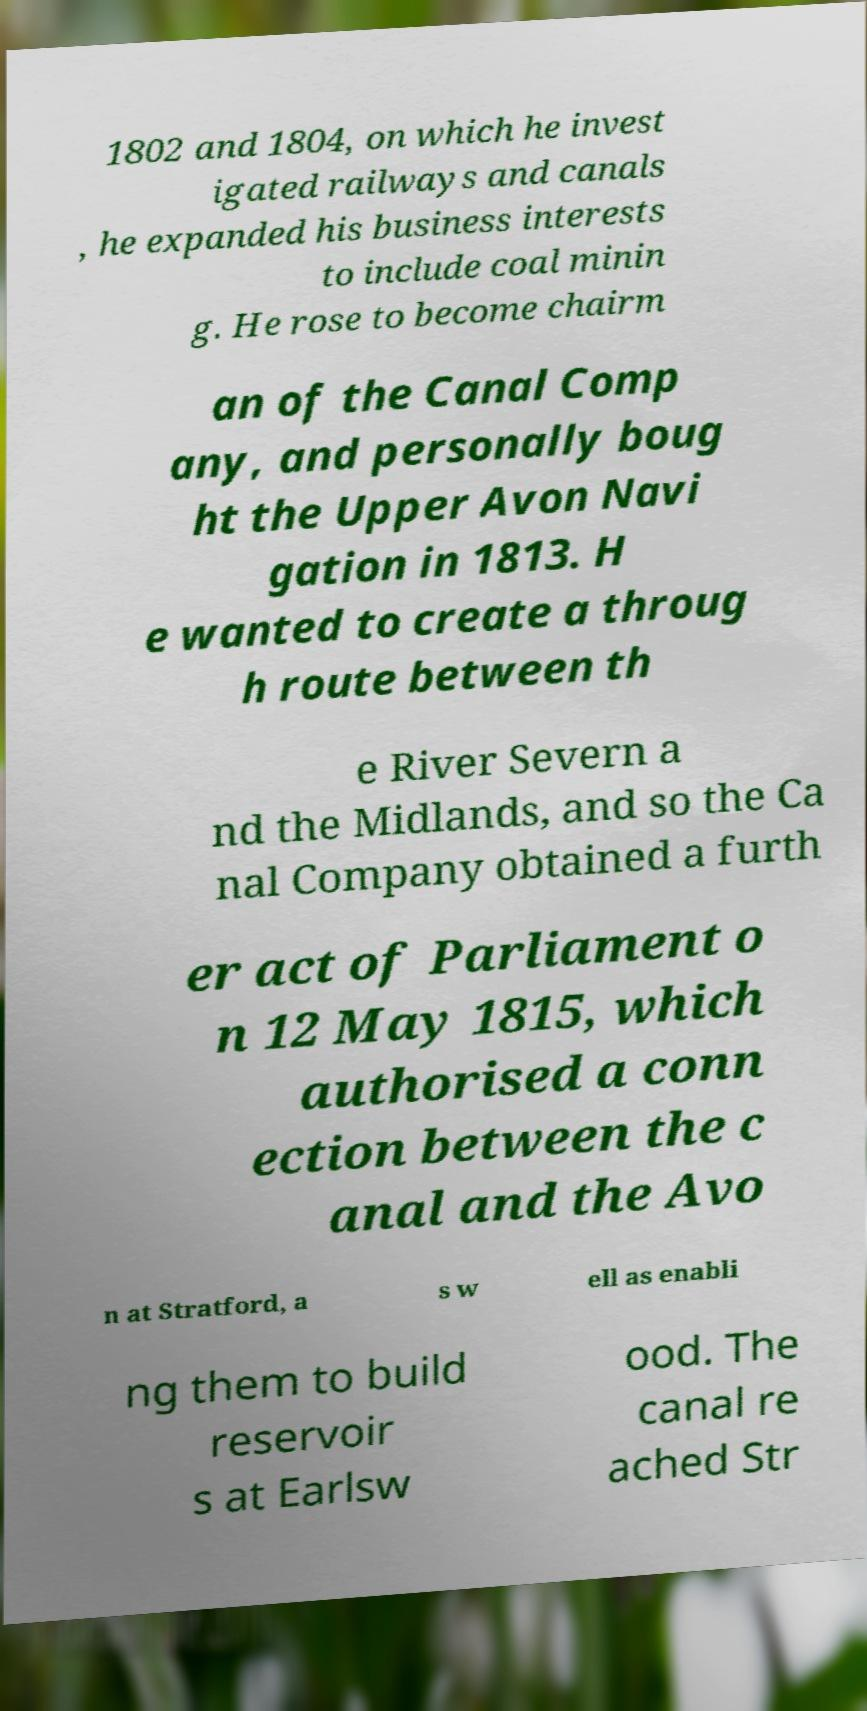I need the written content from this picture converted into text. Can you do that? 1802 and 1804, on which he invest igated railways and canals , he expanded his business interests to include coal minin g. He rose to become chairm an of the Canal Comp any, and personally boug ht the Upper Avon Navi gation in 1813. H e wanted to create a throug h route between th e River Severn a nd the Midlands, and so the Ca nal Company obtained a furth er act of Parliament o n 12 May 1815, which authorised a conn ection between the c anal and the Avo n at Stratford, a s w ell as enabli ng them to build reservoir s at Earlsw ood. The canal re ached Str 